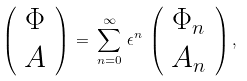Convert formula to latex. <formula><loc_0><loc_0><loc_500><loc_500>\left ( \begin{array} { c } \Phi \\ { A } \end{array} \right ) \, = \, \sum _ { n = 0 } ^ { \infty } \, \epsilon ^ { n } \, \left ( \begin{array} { c } \Phi _ { n } \\ { A } _ { n } \end{array} \right ) ,</formula> 